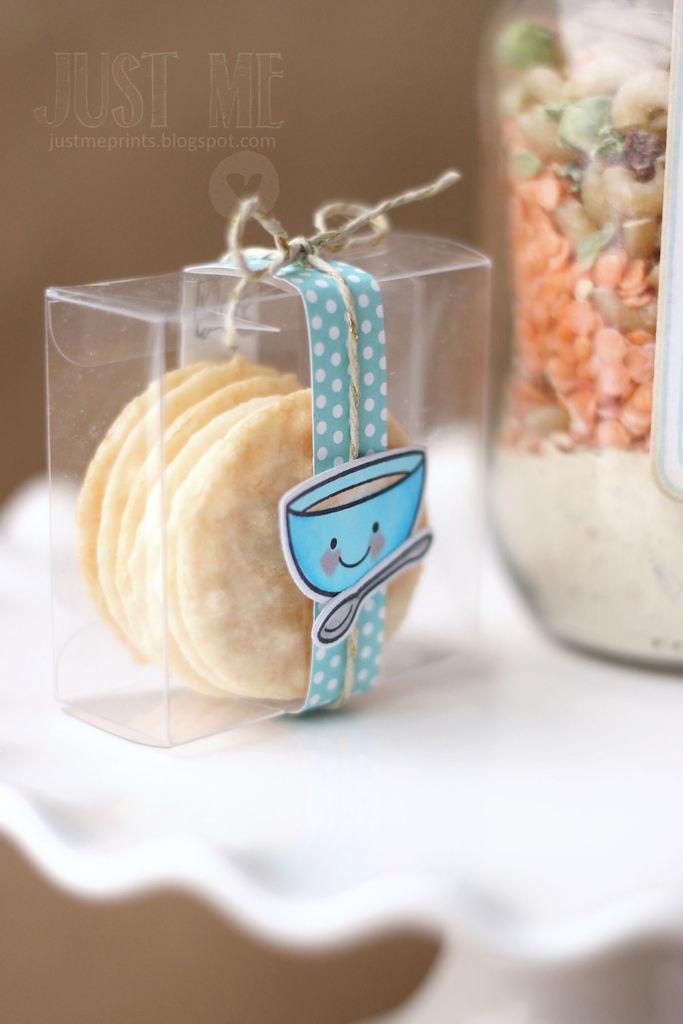Could you give a brief overview of what you see in this image? In the picture I can see some food item is kept in the transparent box which is tied with blue color ribbon and here I can see a jar in which few food items are placed. These two are placed on a white color surface and this part of the image is blurred. Here I can see the watermark at the top left side of the image. 